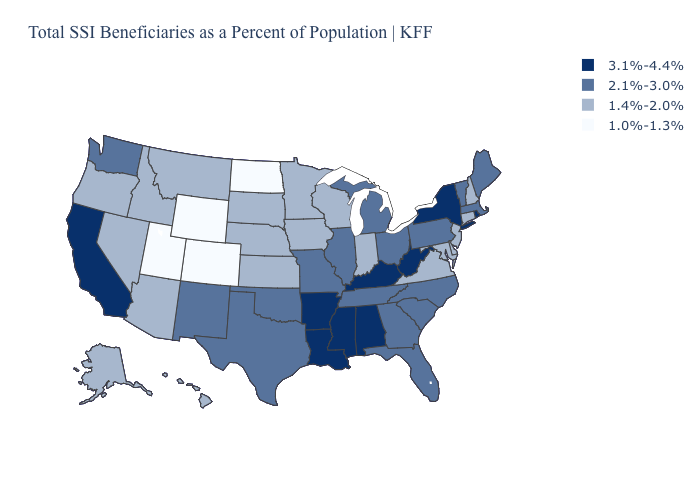What is the value of New Mexico?
Concise answer only. 2.1%-3.0%. What is the lowest value in the USA?
Short answer required. 1.0%-1.3%. Among the states that border Vermont , does New York have the highest value?
Give a very brief answer. Yes. Does New Mexico have the same value as Vermont?
Write a very short answer. Yes. Name the states that have a value in the range 2.1%-3.0%?
Short answer required. Florida, Georgia, Illinois, Maine, Massachusetts, Michigan, Missouri, New Mexico, North Carolina, Ohio, Oklahoma, Pennsylvania, South Carolina, Tennessee, Texas, Vermont, Washington. Among the states that border Nebraska , does Colorado have the lowest value?
Keep it brief. Yes. Does Iowa have the same value as Wyoming?
Be succinct. No. Name the states that have a value in the range 2.1%-3.0%?
Concise answer only. Florida, Georgia, Illinois, Maine, Massachusetts, Michigan, Missouri, New Mexico, North Carolina, Ohio, Oklahoma, Pennsylvania, South Carolina, Tennessee, Texas, Vermont, Washington. Which states have the lowest value in the South?
Concise answer only. Delaware, Maryland, Virginia. What is the value of Ohio?
Short answer required. 2.1%-3.0%. Does Kentucky have the highest value in the USA?
Concise answer only. Yes. What is the value of Illinois?
Give a very brief answer. 2.1%-3.0%. Which states have the lowest value in the USA?
Answer briefly. Colorado, North Dakota, Utah, Wyoming. Name the states that have a value in the range 2.1%-3.0%?
Write a very short answer. Florida, Georgia, Illinois, Maine, Massachusetts, Michigan, Missouri, New Mexico, North Carolina, Ohio, Oklahoma, Pennsylvania, South Carolina, Tennessee, Texas, Vermont, Washington. Does the first symbol in the legend represent the smallest category?
Give a very brief answer. No. 